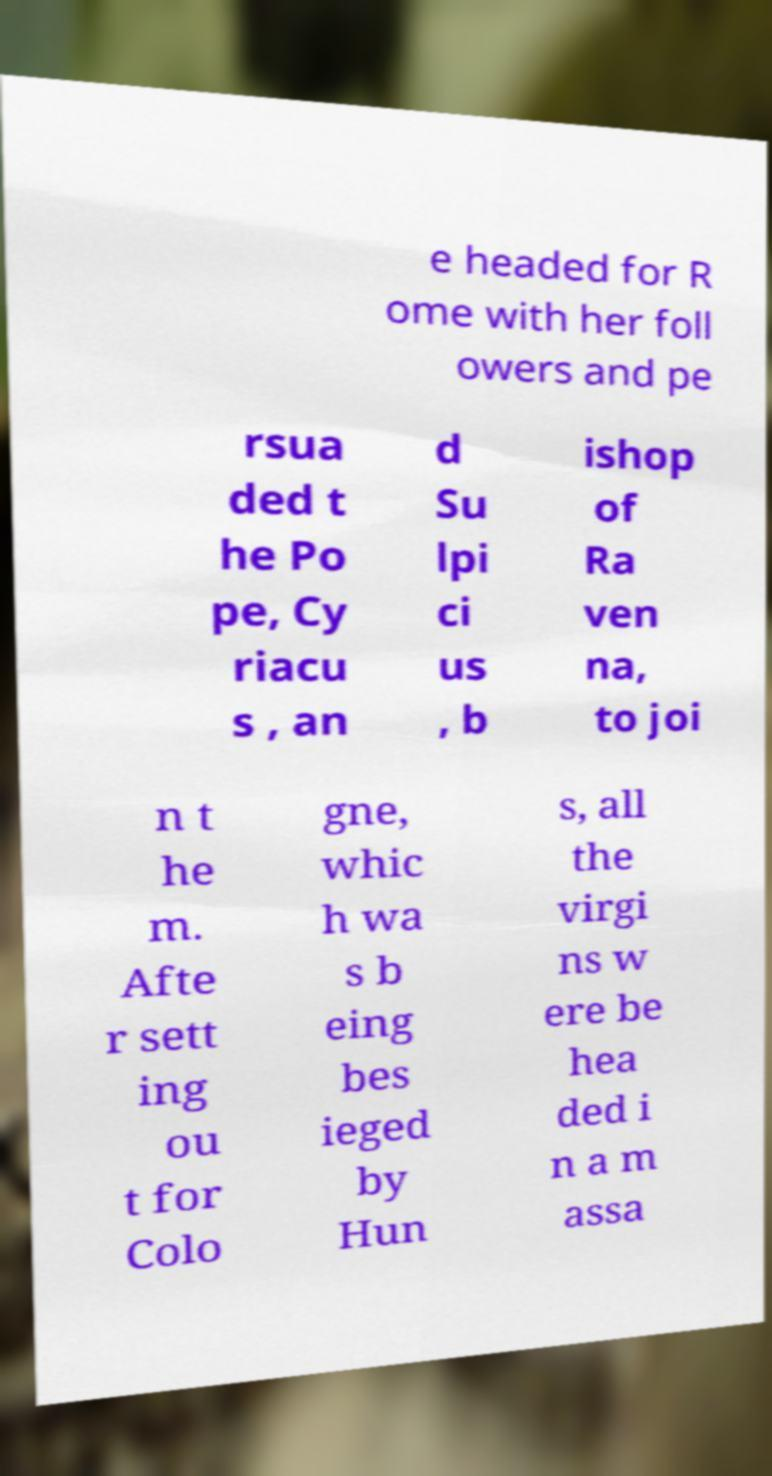For documentation purposes, I need the text within this image transcribed. Could you provide that? e headed for R ome with her foll owers and pe rsua ded t he Po pe, Cy riacu s , an d Su lpi ci us , b ishop of Ra ven na, to joi n t he m. Afte r sett ing ou t for Colo gne, whic h wa s b eing bes ieged by Hun s, all the virgi ns w ere be hea ded i n a m assa 